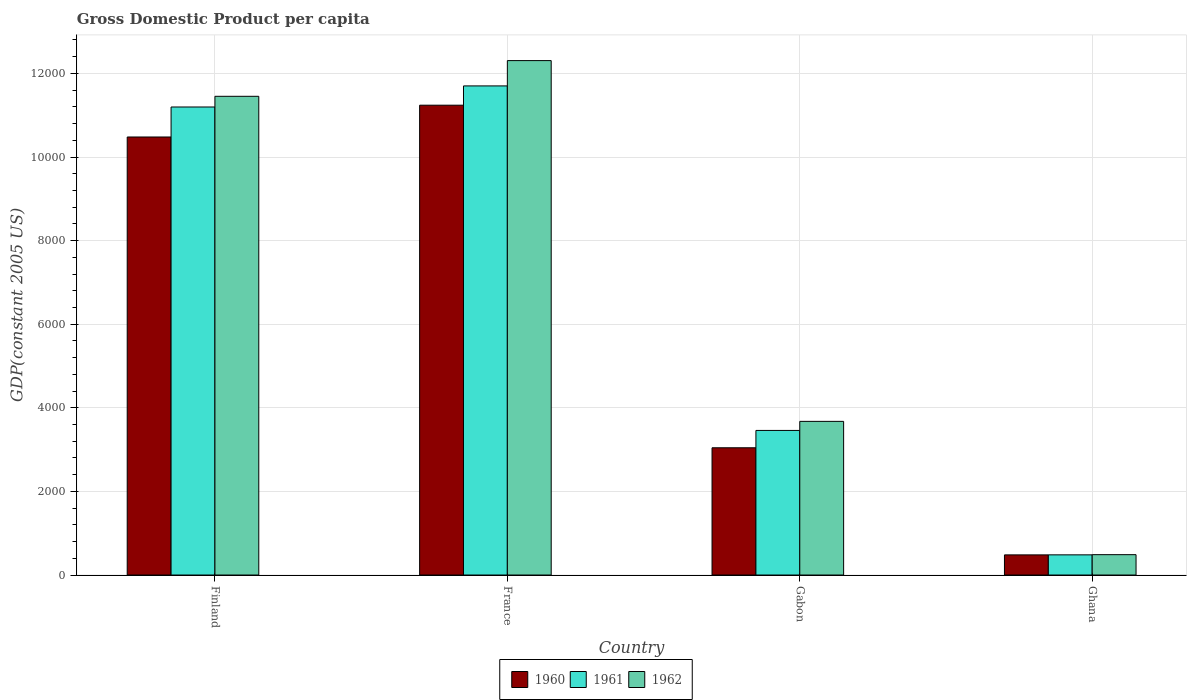How many different coloured bars are there?
Provide a succinct answer. 3. How many groups of bars are there?
Provide a short and direct response. 4. Are the number of bars per tick equal to the number of legend labels?
Your answer should be very brief. Yes. How many bars are there on the 2nd tick from the right?
Keep it short and to the point. 3. What is the GDP per capita in 1961 in Gabon?
Provide a short and direct response. 3459.15. Across all countries, what is the maximum GDP per capita in 1960?
Your answer should be compact. 1.12e+04. Across all countries, what is the minimum GDP per capita in 1961?
Make the answer very short. 482.59. What is the total GDP per capita in 1961 in the graph?
Offer a very short reply. 2.68e+04. What is the difference between the GDP per capita in 1960 in Gabon and that in Ghana?
Keep it short and to the point. 2562.54. What is the difference between the GDP per capita in 1960 in Gabon and the GDP per capita in 1961 in Finland?
Make the answer very short. -8152.08. What is the average GDP per capita in 1962 per country?
Your answer should be compact. 6980.21. What is the difference between the GDP per capita of/in 1962 and GDP per capita of/in 1961 in Ghana?
Offer a very short reply. 4.31. What is the ratio of the GDP per capita in 1961 in France to that in Gabon?
Provide a succinct answer. 3.38. Is the GDP per capita in 1962 in Finland less than that in Gabon?
Provide a succinct answer. No. Is the difference between the GDP per capita in 1962 in France and Gabon greater than the difference between the GDP per capita in 1961 in France and Gabon?
Your response must be concise. Yes. What is the difference between the highest and the second highest GDP per capita in 1961?
Provide a short and direct response. 7737.1. What is the difference between the highest and the lowest GDP per capita in 1960?
Make the answer very short. 1.08e+04. Is it the case that in every country, the sum of the GDP per capita in 1960 and GDP per capita in 1962 is greater than the GDP per capita in 1961?
Provide a succinct answer. Yes. How many bars are there?
Make the answer very short. 12. Are all the bars in the graph horizontal?
Provide a succinct answer. No. How many countries are there in the graph?
Provide a short and direct response. 4. What is the difference between two consecutive major ticks on the Y-axis?
Your answer should be very brief. 2000. Are the values on the major ticks of Y-axis written in scientific E-notation?
Your answer should be compact. No. Does the graph contain any zero values?
Offer a terse response. No. Where does the legend appear in the graph?
Provide a succinct answer. Bottom center. How many legend labels are there?
Offer a very short reply. 3. What is the title of the graph?
Give a very brief answer. Gross Domestic Product per capita. What is the label or title of the X-axis?
Keep it short and to the point. Country. What is the label or title of the Y-axis?
Ensure brevity in your answer.  GDP(constant 2005 US). What is the GDP(constant 2005 US) of 1960 in Finland?
Offer a terse response. 1.05e+04. What is the GDP(constant 2005 US) of 1961 in Finland?
Your response must be concise. 1.12e+04. What is the GDP(constant 2005 US) of 1962 in Finland?
Make the answer very short. 1.15e+04. What is the GDP(constant 2005 US) in 1960 in France?
Keep it short and to the point. 1.12e+04. What is the GDP(constant 2005 US) in 1961 in France?
Provide a succinct answer. 1.17e+04. What is the GDP(constant 2005 US) of 1962 in France?
Your answer should be very brief. 1.23e+04. What is the GDP(constant 2005 US) of 1960 in Gabon?
Your answer should be very brief. 3044.16. What is the GDP(constant 2005 US) in 1961 in Gabon?
Provide a short and direct response. 3459.15. What is the GDP(constant 2005 US) in 1962 in Gabon?
Give a very brief answer. 3675.76. What is the GDP(constant 2005 US) of 1960 in Ghana?
Offer a terse response. 481.62. What is the GDP(constant 2005 US) in 1961 in Ghana?
Provide a succinct answer. 482.59. What is the GDP(constant 2005 US) of 1962 in Ghana?
Offer a very short reply. 486.9. Across all countries, what is the maximum GDP(constant 2005 US) of 1960?
Offer a terse response. 1.12e+04. Across all countries, what is the maximum GDP(constant 2005 US) in 1961?
Provide a short and direct response. 1.17e+04. Across all countries, what is the maximum GDP(constant 2005 US) of 1962?
Provide a short and direct response. 1.23e+04. Across all countries, what is the minimum GDP(constant 2005 US) of 1960?
Ensure brevity in your answer.  481.62. Across all countries, what is the minimum GDP(constant 2005 US) in 1961?
Your response must be concise. 482.59. Across all countries, what is the minimum GDP(constant 2005 US) of 1962?
Keep it short and to the point. 486.9. What is the total GDP(constant 2005 US) in 1960 in the graph?
Offer a very short reply. 2.52e+04. What is the total GDP(constant 2005 US) of 1961 in the graph?
Offer a very short reply. 2.68e+04. What is the total GDP(constant 2005 US) in 1962 in the graph?
Provide a succinct answer. 2.79e+04. What is the difference between the GDP(constant 2005 US) of 1960 in Finland and that in France?
Offer a very short reply. -760.61. What is the difference between the GDP(constant 2005 US) of 1961 in Finland and that in France?
Make the answer very short. -504.31. What is the difference between the GDP(constant 2005 US) in 1962 in Finland and that in France?
Ensure brevity in your answer.  -854.21. What is the difference between the GDP(constant 2005 US) of 1960 in Finland and that in Gabon?
Offer a very short reply. 7434.51. What is the difference between the GDP(constant 2005 US) in 1961 in Finland and that in Gabon?
Ensure brevity in your answer.  7737.1. What is the difference between the GDP(constant 2005 US) in 1962 in Finland and that in Gabon?
Provide a succinct answer. 7776.21. What is the difference between the GDP(constant 2005 US) in 1960 in Finland and that in Ghana?
Ensure brevity in your answer.  9997.05. What is the difference between the GDP(constant 2005 US) of 1961 in Finland and that in Ghana?
Your answer should be compact. 1.07e+04. What is the difference between the GDP(constant 2005 US) of 1962 in Finland and that in Ghana?
Ensure brevity in your answer.  1.10e+04. What is the difference between the GDP(constant 2005 US) of 1960 in France and that in Gabon?
Your response must be concise. 8195.12. What is the difference between the GDP(constant 2005 US) of 1961 in France and that in Gabon?
Keep it short and to the point. 8241.41. What is the difference between the GDP(constant 2005 US) in 1962 in France and that in Gabon?
Provide a short and direct response. 8630.42. What is the difference between the GDP(constant 2005 US) of 1960 in France and that in Ghana?
Your answer should be very brief. 1.08e+04. What is the difference between the GDP(constant 2005 US) of 1961 in France and that in Ghana?
Offer a very short reply. 1.12e+04. What is the difference between the GDP(constant 2005 US) of 1962 in France and that in Ghana?
Your answer should be very brief. 1.18e+04. What is the difference between the GDP(constant 2005 US) of 1960 in Gabon and that in Ghana?
Provide a succinct answer. 2562.54. What is the difference between the GDP(constant 2005 US) in 1961 in Gabon and that in Ghana?
Your response must be concise. 2976.55. What is the difference between the GDP(constant 2005 US) of 1962 in Gabon and that in Ghana?
Provide a succinct answer. 3188.86. What is the difference between the GDP(constant 2005 US) of 1960 in Finland and the GDP(constant 2005 US) of 1961 in France?
Make the answer very short. -1221.89. What is the difference between the GDP(constant 2005 US) in 1960 in Finland and the GDP(constant 2005 US) in 1962 in France?
Your response must be concise. -1827.51. What is the difference between the GDP(constant 2005 US) of 1961 in Finland and the GDP(constant 2005 US) of 1962 in France?
Keep it short and to the point. -1109.94. What is the difference between the GDP(constant 2005 US) of 1960 in Finland and the GDP(constant 2005 US) of 1961 in Gabon?
Offer a terse response. 7019.52. What is the difference between the GDP(constant 2005 US) in 1960 in Finland and the GDP(constant 2005 US) in 1962 in Gabon?
Ensure brevity in your answer.  6802.91. What is the difference between the GDP(constant 2005 US) of 1961 in Finland and the GDP(constant 2005 US) of 1962 in Gabon?
Ensure brevity in your answer.  7520.48. What is the difference between the GDP(constant 2005 US) of 1960 in Finland and the GDP(constant 2005 US) of 1961 in Ghana?
Your answer should be very brief. 9996.08. What is the difference between the GDP(constant 2005 US) of 1960 in Finland and the GDP(constant 2005 US) of 1962 in Ghana?
Offer a terse response. 9991.77. What is the difference between the GDP(constant 2005 US) of 1961 in Finland and the GDP(constant 2005 US) of 1962 in Ghana?
Offer a terse response. 1.07e+04. What is the difference between the GDP(constant 2005 US) of 1960 in France and the GDP(constant 2005 US) of 1961 in Gabon?
Your response must be concise. 7780.13. What is the difference between the GDP(constant 2005 US) of 1960 in France and the GDP(constant 2005 US) of 1962 in Gabon?
Your answer should be very brief. 7563.52. What is the difference between the GDP(constant 2005 US) in 1961 in France and the GDP(constant 2005 US) in 1962 in Gabon?
Give a very brief answer. 8024.79. What is the difference between the GDP(constant 2005 US) in 1960 in France and the GDP(constant 2005 US) in 1961 in Ghana?
Your response must be concise. 1.08e+04. What is the difference between the GDP(constant 2005 US) in 1960 in France and the GDP(constant 2005 US) in 1962 in Ghana?
Make the answer very short. 1.08e+04. What is the difference between the GDP(constant 2005 US) of 1961 in France and the GDP(constant 2005 US) of 1962 in Ghana?
Offer a very short reply. 1.12e+04. What is the difference between the GDP(constant 2005 US) of 1960 in Gabon and the GDP(constant 2005 US) of 1961 in Ghana?
Provide a succinct answer. 2561.57. What is the difference between the GDP(constant 2005 US) of 1960 in Gabon and the GDP(constant 2005 US) of 1962 in Ghana?
Provide a succinct answer. 2557.26. What is the difference between the GDP(constant 2005 US) in 1961 in Gabon and the GDP(constant 2005 US) in 1962 in Ghana?
Keep it short and to the point. 2972.24. What is the average GDP(constant 2005 US) in 1960 per country?
Your answer should be compact. 6310.93. What is the average GDP(constant 2005 US) of 1961 per country?
Offer a very short reply. 6709.64. What is the average GDP(constant 2005 US) of 1962 per country?
Offer a very short reply. 6980.2. What is the difference between the GDP(constant 2005 US) of 1960 and GDP(constant 2005 US) of 1961 in Finland?
Offer a terse response. -717.58. What is the difference between the GDP(constant 2005 US) of 1960 and GDP(constant 2005 US) of 1962 in Finland?
Provide a succinct answer. -973.3. What is the difference between the GDP(constant 2005 US) of 1961 and GDP(constant 2005 US) of 1962 in Finland?
Your answer should be very brief. -255.73. What is the difference between the GDP(constant 2005 US) of 1960 and GDP(constant 2005 US) of 1961 in France?
Offer a terse response. -461.28. What is the difference between the GDP(constant 2005 US) of 1960 and GDP(constant 2005 US) of 1962 in France?
Keep it short and to the point. -1066.9. What is the difference between the GDP(constant 2005 US) in 1961 and GDP(constant 2005 US) in 1962 in France?
Provide a short and direct response. -605.63. What is the difference between the GDP(constant 2005 US) of 1960 and GDP(constant 2005 US) of 1961 in Gabon?
Your answer should be compact. -414.98. What is the difference between the GDP(constant 2005 US) in 1960 and GDP(constant 2005 US) in 1962 in Gabon?
Give a very brief answer. -631.6. What is the difference between the GDP(constant 2005 US) in 1961 and GDP(constant 2005 US) in 1962 in Gabon?
Your answer should be compact. -216.62. What is the difference between the GDP(constant 2005 US) in 1960 and GDP(constant 2005 US) in 1961 in Ghana?
Give a very brief answer. -0.97. What is the difference between the GDP(constant 2005 US) of 1960 and GDP(constant 2005 US) of 1962 in Ghana?
Offer a terse response. -5.28. What is the difference between the GDP(constant 2005 US) in 1961 and GDP(constant 2005 US) in 1962 in Ghana?
Offer a very short reply. -4.31. What is the ratio of the GDP(constant 2005 US) in 1960 in Finland to that in France?
Keep it short and to the point. 0.93. What is the ratio of the GDP(constant 2005 US) in 1961 in Finland to that in France?
Ensure brevity in your answer.  0.96. What is the ratio of the GDP(constant 2005 US) of 1962 in Finland to that in France?
Your response must be concise. 0.93. What is the ratio of the GDP(constant 2005 US) in 1960 in Finland to that in Gabon?
Keep it short and to the point. 3.44. What is the ratio of the GDP(constant 2005 US) of 1961 in Finland to that in Gabon?
Offer a terse response. 3.24. What is the ratio of the GDP(constant 2005 US) in 1962 in Finland to that in Gabon?
Give a very brief answer. 3.12. What is the ratio of the GDP(constant 2005 US) of 1960 in Finland to that in Ghana?
Offer a very short reply. 21.76. What is the ratio of the GDP(constant 2005 US) in 1961 in Finland to that in Ghana?
Offer a terse response. 23.2. What is the ratio of the GDP(constant 2005 US) in 1962 in Finland to that in Ghana?
Your answer should be compact. 23.52. What is the ratio of the GDP(constant 2005 US) of 1960 in France to that in Gabon?
Offer a very short reply. 3.69. What is the ratio of the GDP(constant 2005 US) of 1961 in France to that in Gabon?
Offer a terse response. 3.38. What is the ratio of the GDP(constant 2005 US) in 1962 in France to that in Gabon?
Your response must be concise. 3.35. What is the ratio of the GDP(constant 2005 US) in 1960 in France to that in Ghana?
Make the answer very short. 23.34. What is the ratio of the GDP(constant 2005 US) of 1961 in France to that in Ghana?
Provide a short and direct response. 24.25. What is the ratio of the GDP(constant 2005 US) of 1962 in France to that in Ghana?
Your answer should be very brief. 25.27. What is the ratio of the GDP(constant 2005 US) in 1960 in Gabon to that in Ghana?
Your response must be concise. 6.32. What is the ratio of the GDP(constant 2005 US) in 1961 in Gabon to that in Ghana?
Offer a very short reply. 7.17. What is the ratio of the GDP(constant 2005 US) in 1962 in Gabon to that in Ghana?
Provide a short and direct response. 7.55. What is the difference between the highest and the second highest GDP(constant 2005 US) of 1960?
Your response must be concise. 760.61. What is the difference between the highest and the second highest GDP(constant 2005 US) in 1961?
Keep it short and to the point. 504.31. What is the difference between the highest and the second highest GDP(constant 2005 US) of 1962?
Make the answer very short. 854.21. What is the difference between the highest and the lowest GDP(constant 2005 US) in 1960?
Give a very brief answer. 1.08e+04. What is the difference between the highest and the lowest GDP(constant 2005 US) of 1961?
Your answer should be very brief. 1.12e+04. What is the difference between the highest and the lowest GDP(constant 2005 US) of 1962?
Keep it short and to the point. 1.18e+04. 